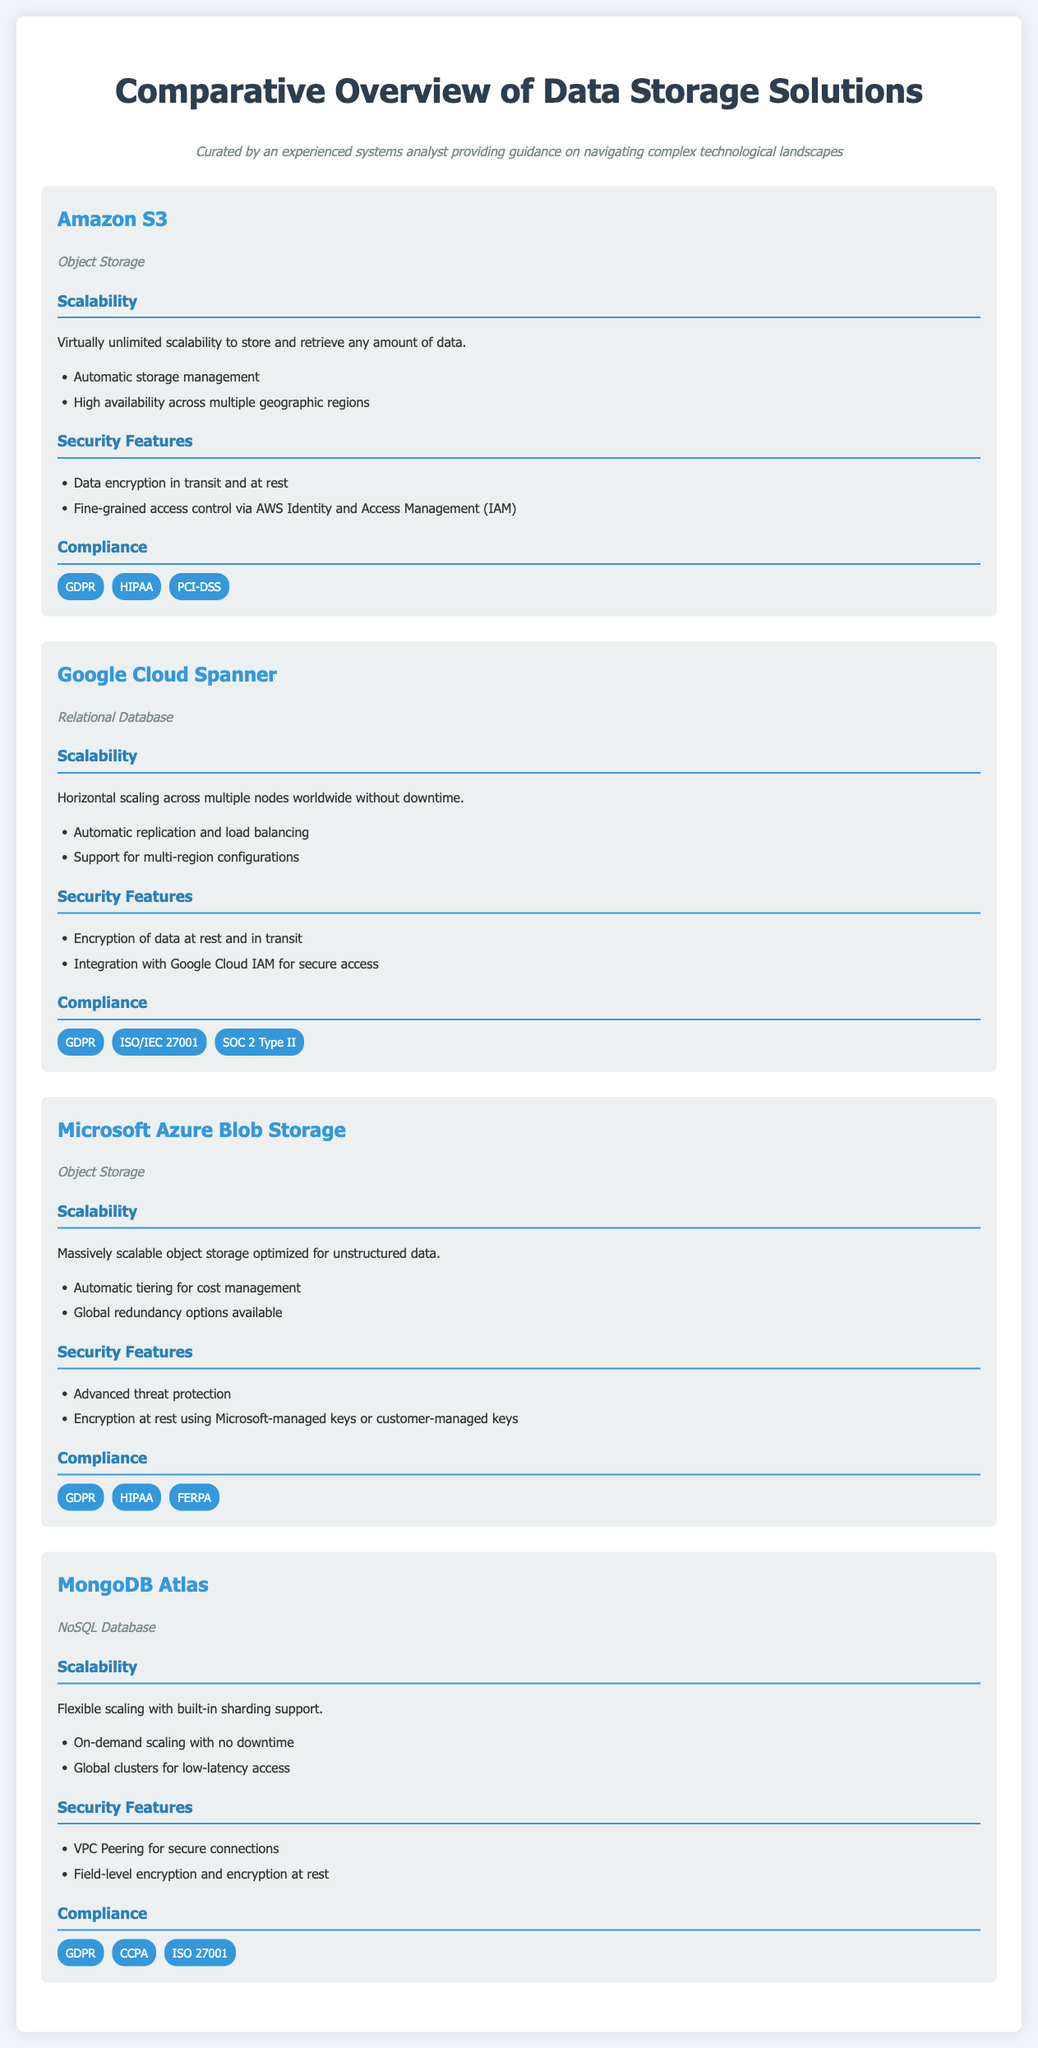What is the type of Amazon S3? Amazon S3 is categorized as an object storage solution in the document.
Answer: Object Storage What security feature does Microsoft Azure Blob Storage provide? One of the listed security features for Microsoft Azure Blob Storage is advanced threat protection.
Answer: Advanced threat protection How many compliance tags does Google Cloud Spanner have? The document lists three compliance tags for Google Cloud Spanner, which are GDPR, ISO/IEC 27001, and SOC 2 Type II.
Answer: Three What is the scalability feature of MongoDB Atlas? MongoDB Atlas's scalability feature highlighted is flexible scaling with built-in sharding support.
Answer: Flexible scaling with built-in sharding support Which data storage solution offers encryption at rest using customer-managed keys? Microsoft Azure Blob Storage provides the option for encryption at rest using customer-managed keys.
Answer: Microsoft Azure Blob Storage What does Amazon S3 support regarding geographic regions? Amazon S3 supports high availability across multiple geographic regions.
Answer: High availability across multiple geographic regions Which solution allows for on-demand scaling with no downtime? The solution that allows for on-demand scaling with no downtime is MongoDB Atlas.
Answer: MongoDB Atlas Name one compliance requirement for MongoDB Atlas. One of the compliance requirements for MongoDB Atlas is GDPR.
Answer: GDPR What is the primary database type of Google Cloud Spanner? The primary database type for Google Cloud Spanner is a relational database.
Answer: Relational Database 